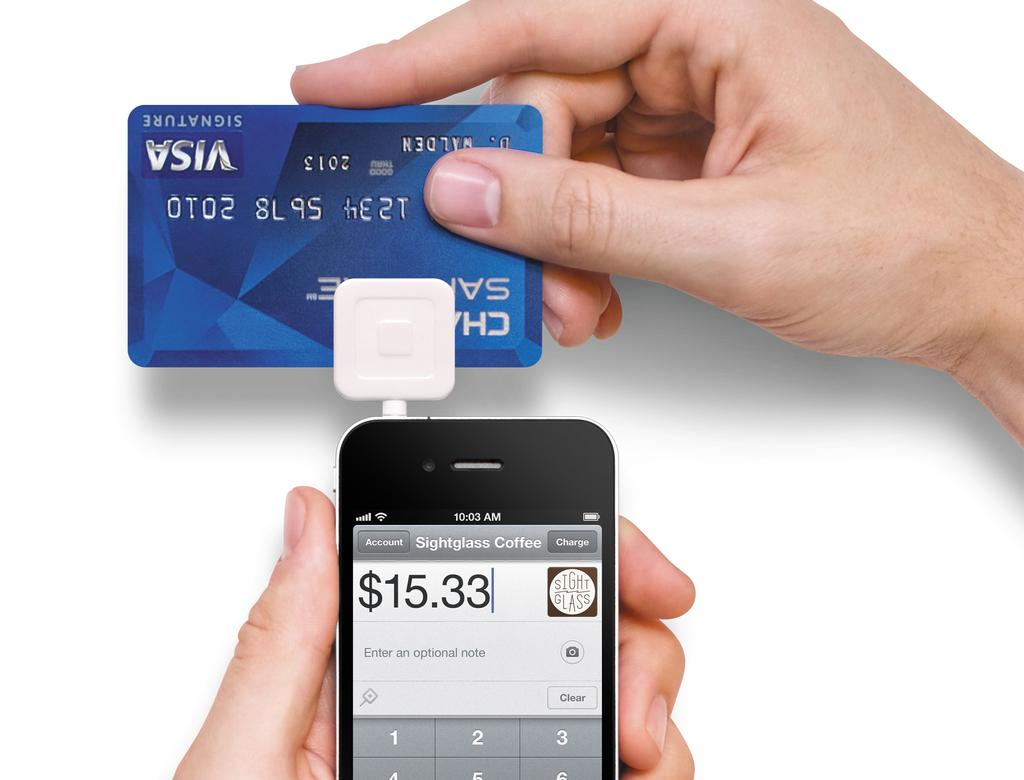<image>
Share a concise interpretation of the image provided. A bill of $15.33 is paid for Sightglass coffee. 